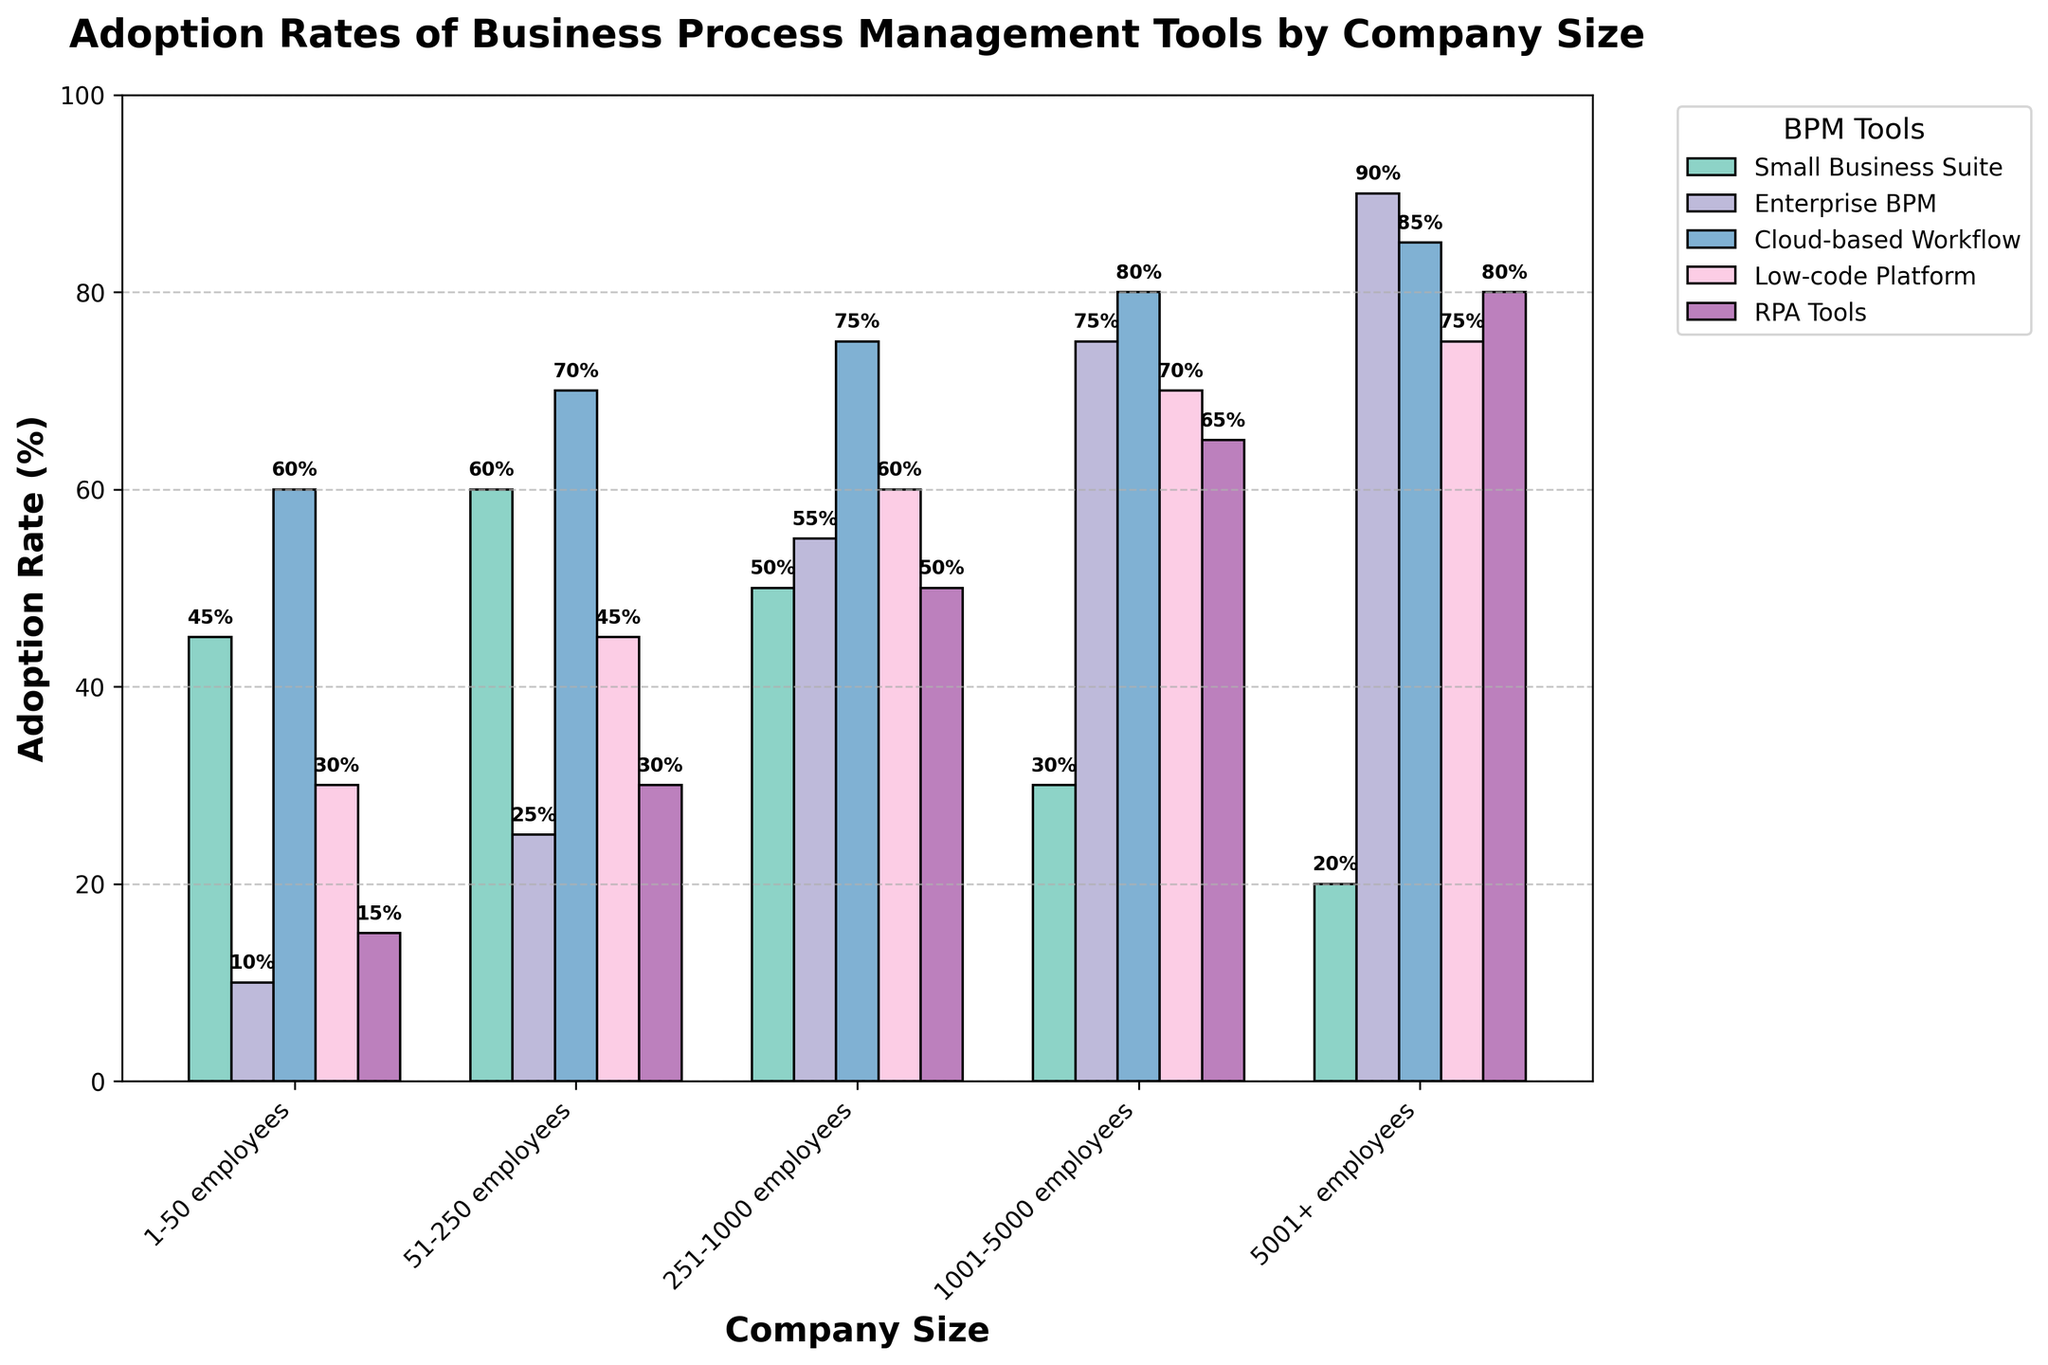What's the most adopted BPM tool among companies with 251-1000 employees? Companies with 251-1000 employees have the highest adoption rate for "Cloud-based Workflow" at 75% as seen from the tallest bar for that category in the bar chart.
Answer: Cloud-based Workflow Which company size has the highest adoption rate for RPA Tools? By reviewing the heights of the RPA Tools bars, you can see the highest bar is for the company size "5001+ employees" at 80%.
Answer: 5001+ employees Is the adoption rate of Low-code Platform higher for small businesses (1-50 employees) or medium-sized businesses (51-250 employees)? Comparing the bars, the adoption rate for Low-code Platform is 30% for small businesses and 45% for medium-sized businesses. Therefore, it is higher for medium-sized businesses.
Answer: Medium-sized businesses What is the difference in adoption rate for Enterprise BPM between companies with 1-50 employees and those with 5001+ employees? The adoption rates are 10% for companies with 1-50 employees and 90% for companies with 5001+ employees. The difference is 90% - 10% = 80%.
Answer: 80% Which BPM tool shows the most consistent adoption rate across all company sizes? By scanning the bars, "RPA Tools" show a relatively smooth increase and uniform heights compared to other tools. It ranges from 15% to 80%, which is more consistent than the other tools.
Answer: RPA Tools What is the average adoption rate of Cloud-based Workflow for companies with 1-50, 51-250, and 251-1000 employees? The adoption rates for Cloud-based Workflow are 60%, 70%, and 75% respectively. The average is (60 + 70 + 75) / 3 = 68%.
Answer: 68% Which category has the highest adoption rate for companies with 1001-5000 employees? The tallest bar for companies with 1001-5000 employees corresponds to "Cloud-based Workflow" with an adoption rate of 80%.
Answer: Cloud-based Workflow How does the adoption rate of Small Business Suite for firms with 51-250 employees compare to that of firms with 5001+ employees? The adoption rate for Small Business Suite is 60% for 51-250 employees and 20% for 5001+ employees. Therefore, it is higher in firms with 51-250 employees.
Answer: Higher in 51-250 employees 